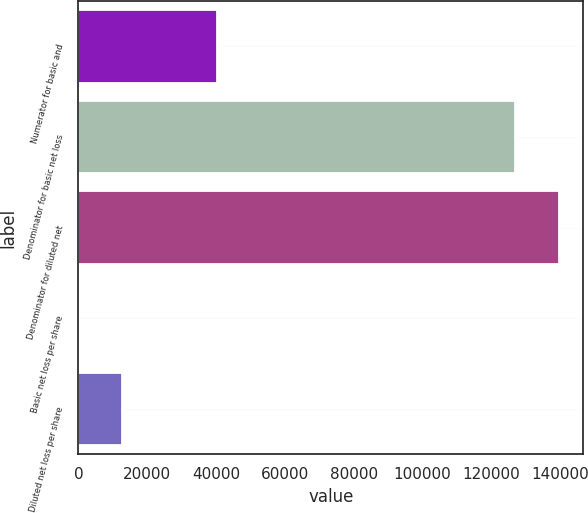Convert chart to OTSL. <chart><loc_0><loc_0><loc_500><loc_500><bar_chart><fcel>Numerator for basic and<fcel>Denominator for basic net loss<fcel>Denominator for diluted net<fcel>Basic net loss per share<fcel>Diluted net loss per share<nl><fcel>40288<fcel>126946<fcel>139641<fcel>0.32<fcel>12694.9<nl></chart> 